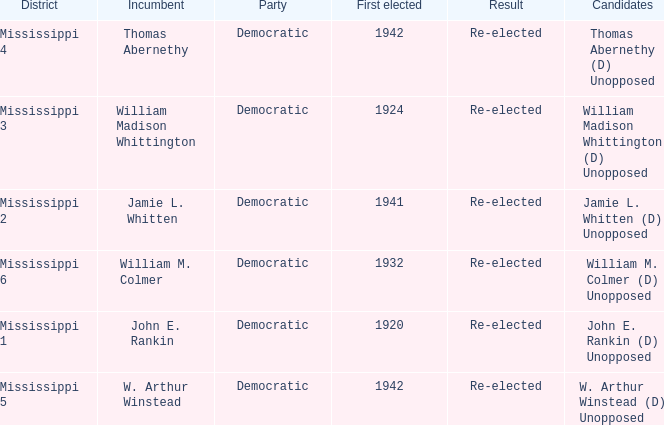Which district is jamie l. whitten from? Mississippi 2. 